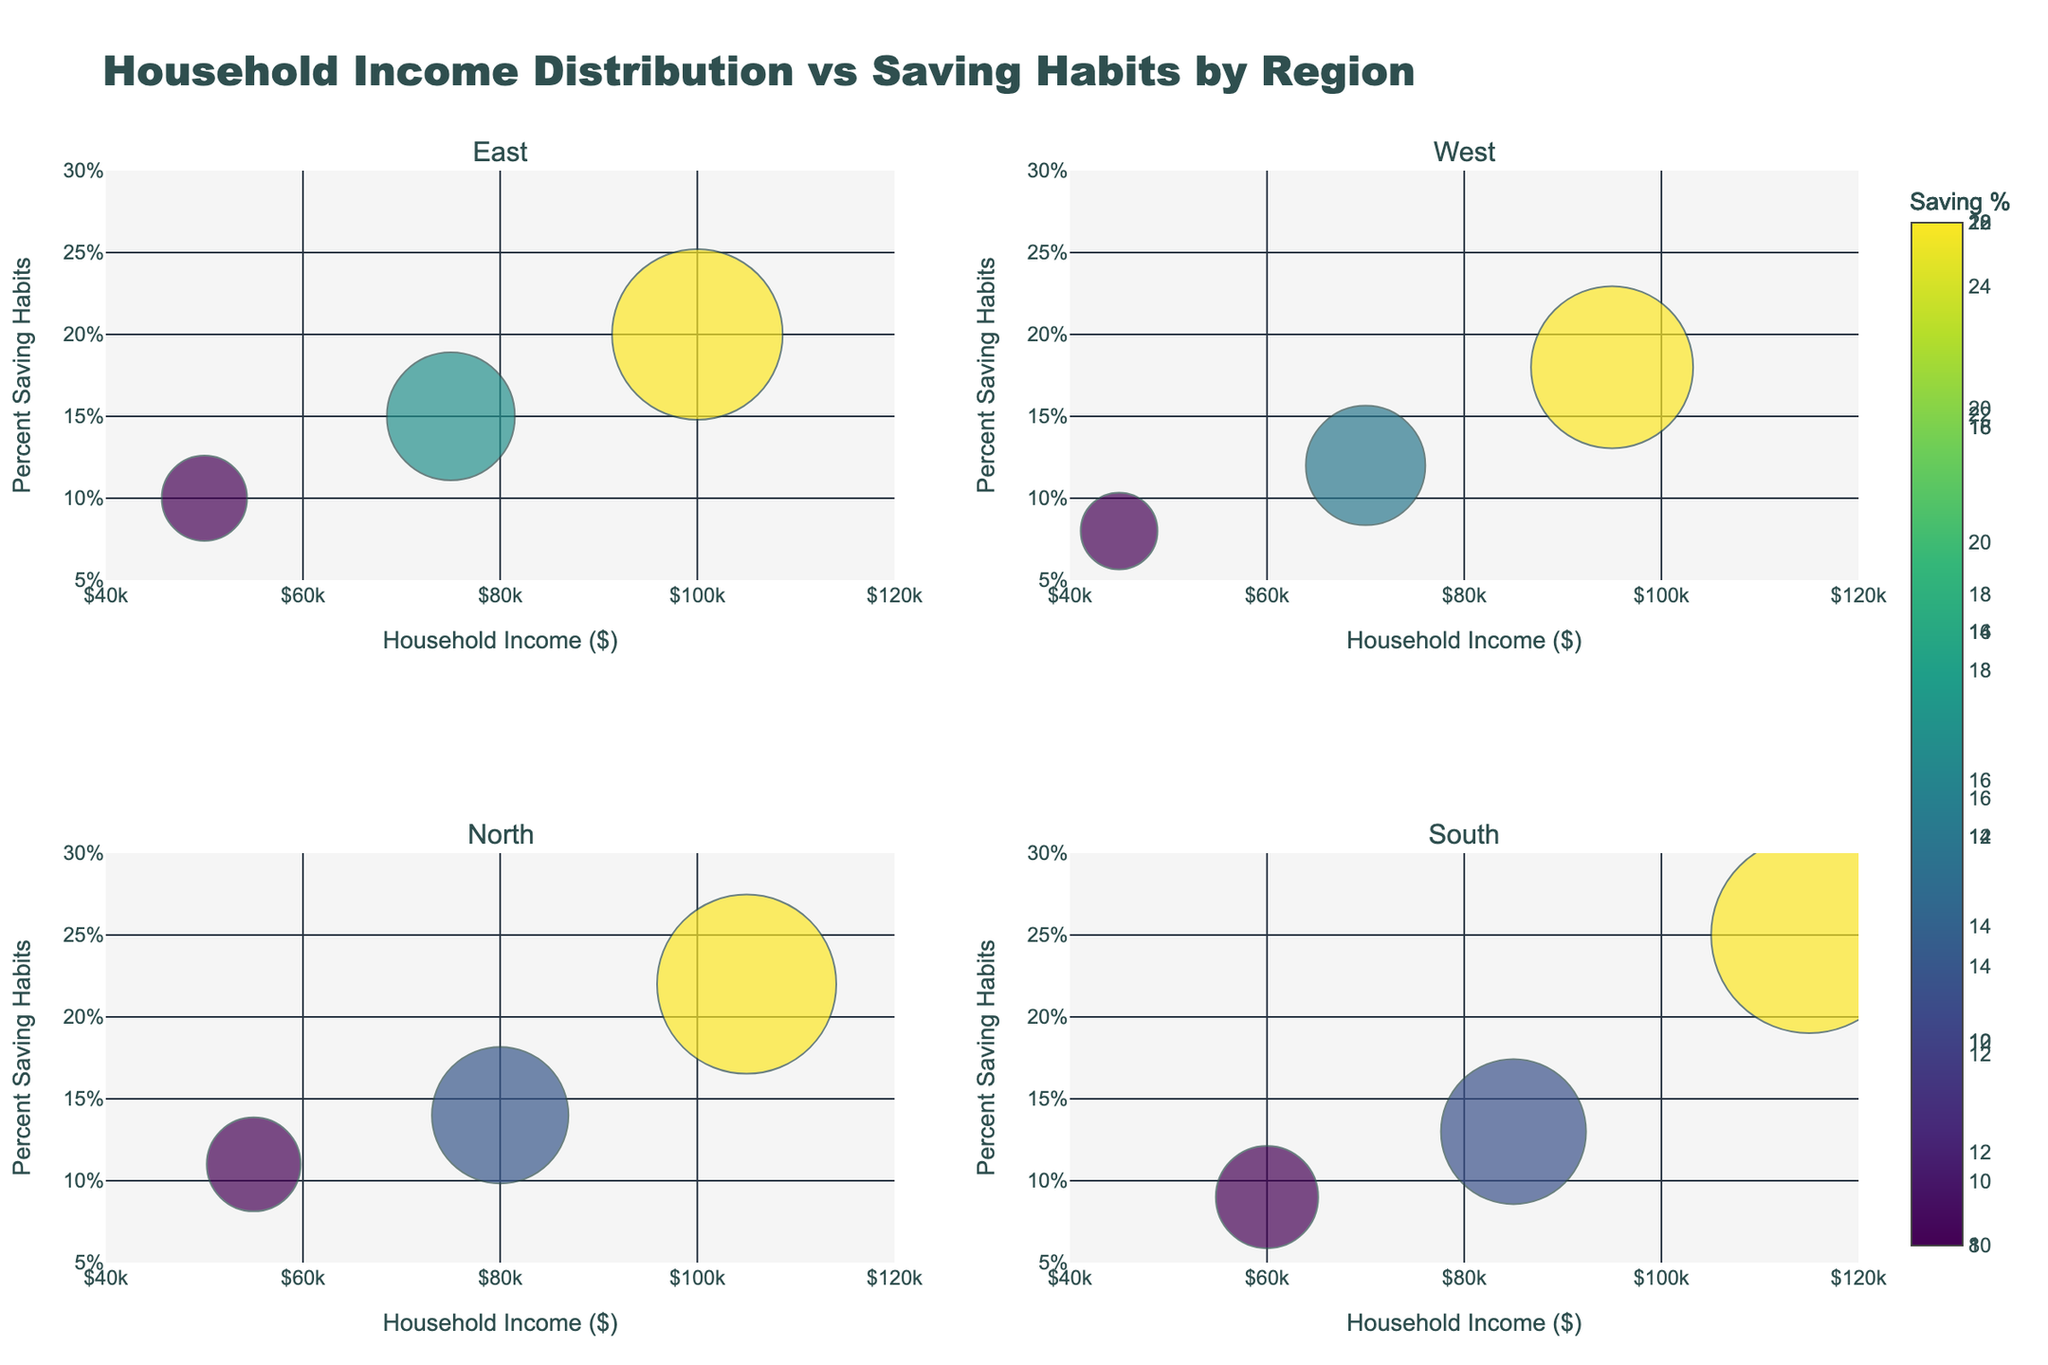How many regions are represented in the figure? The figure is divided into four subplots, each titled with a region name. By looking at the subplot titles, we can count the number of regions.
Answer: 4 What is the range of household income shown on the x-axis? The x-axis visually shows the range of household incomes. The tick marks and labels indicate the lowest value is $40,000 and the highest is $120,000.
Answer: $40,000 to $120,000 Which region has the household with the highest percent saving habits? By examining all the subplots, we find that the South subplot includes a data point with the highest saving percentage at 25%.
Answer: South What is the relationship between household income and percent saving habits in the East region? By observing the East subplot, we see a trend where higher household incomes correspond to higher percentages of saving habits based on the positioning and size of the bubbles.
Answer: Positive correlation Which region exhibits the largest bubble in the figure and what is its household income? The size of the bubbles represents their significance. The largest bubble, as indicated by its size, appears in the South region and corresponds to a household income of $115,000.
Answer: South, $115,000 How many data points are represented in the North region? By counting the number of bubbles in the North subplot, we find there are 3 data points.
Answer: 3 What is the average percent saving habits for the West region? By looking at the West subplot, the saving percentages are 8%, 12%, and 18%. The average is calculated as (8 + 12 + 18) / 3.
Answer: 12.67% Which region has a household with a $75,000 income, and what is their percent saving habit? Each subplot represents a different region. By identifying the bubble at $75,000 in the East subplot, we see it corresponds to a saving percentage of 15%.
Answer: East, 15% Compare the household with the lowest income in the West region to the household with the lowest income in the North region in terms of percent saving habits. The lowest income in the West region is $45,000 with an 8% saving habit. The lowest income in the North region is $55,000 with an 11% saving habit. Comparatively, North has a higher saving percentage.
Answer: North has higher percent saving habits What is the range of percent saving habits displayed on the y-axis? The y-axis visually shows the range of percent saving habits. The tick marks and labels indicate the range from 5% to 30%.
Answer: 5% to 30% 